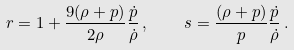<formula> <loc_0><loc_0><loc_500><loc_500>r = 1 + \frac { 9 ( \rho + p ) } { 2 \rho } \frac { \dot { p } } { \dot { \rho } } \, , \quad s = \frac { ( \rho + p ) } { p } \frac { \dot { p } } { \dot { \rho } } \, .</formula> 